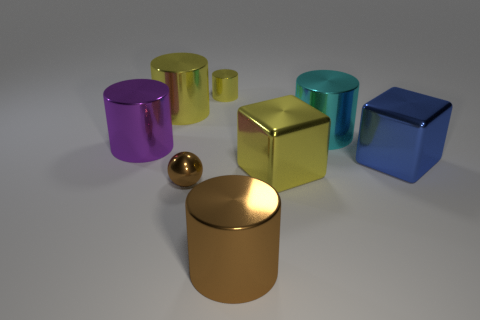How many brown things are large objects or metal cylinders?
Offer a terse response. 1. Is there a metallic block of the same color as the tiny shiny cylinder?
Offer a terse response. Yes. Is there a yellow block that has the same material as the big blue block?
Make the answer very short. Yes. What is the shape of the object that is on the left side of the big brown cylinder and in front of the yellow block?
Your response must be concise. Sphere. How many large objects are yellow matte cubes or purple things?
Your answer should be compact. 1. What is the material of the purple cylinder?
Provide a succinct answer. Metal. How many other objects are the same shape as the cyan shiny thing?
Ensure brevity in your answer.  4. What size is the purple cylinder?
Your answer should be compact. Large. How big is the shiny cylinder that is behind the cyan thing and on the right side of the tiny ball?
Provide a short and direct response. Small. There is a large object right of the large cyan shiny object; what is its shape?
Offer a very short reply. Cube. 